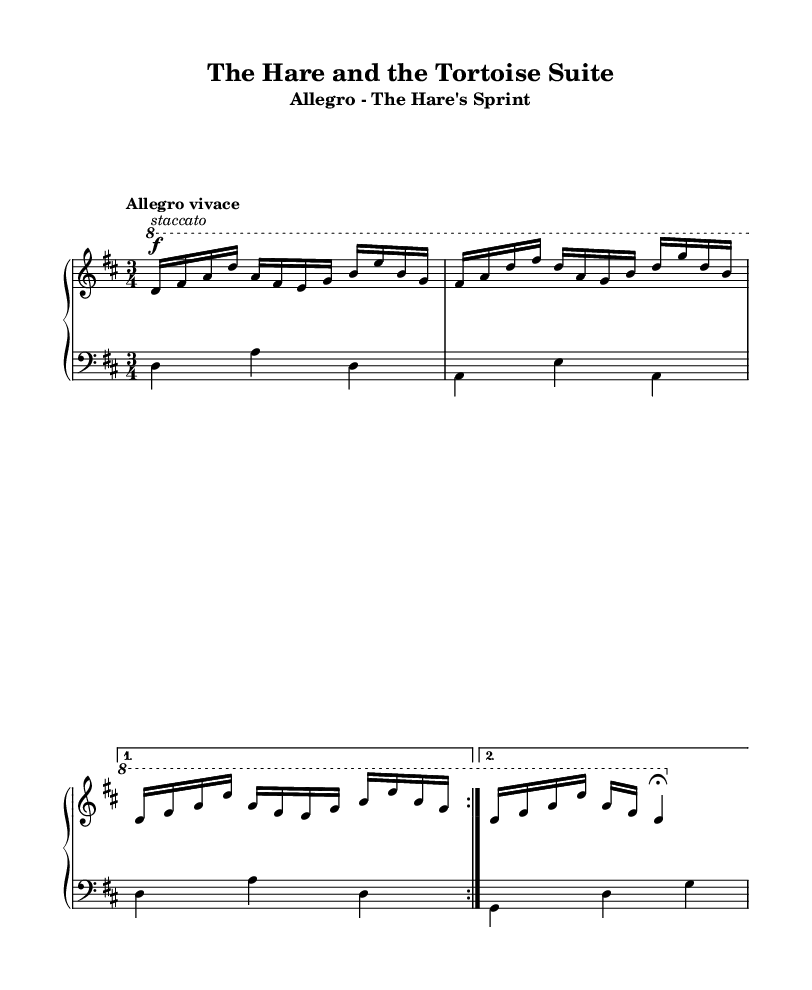What is the key signature of this music? The key signature is D major, which has two sharps (F# and C#). This can be deduced from the initial part of the score beneath the staff, indicating the key signature that governs the piece.
Answer: D major What is the time signature of this music? The time signature shown in the score is 3/4. This indicates that there are three beats in each measure and that a quarter note receives one beat. The time signature is typically found at the beginning of the staff, where it is prominently displayed.
Answer: 3/4 What is the tempo marking for this piece? The tempo marking is "Allegro vivace". This marking signifies a fast and lively tempo, indicating the speed and mood of the piece. Tempo markings are usually presented at the start of the music to guide the performer.
Answer: Allegro vivace How many times does the main motif repeat in the right hand? The main motif in the right hand repeats two times, as indicated by the notation of "volta 2", which shows repeated sections in the music. This repetition is typical in Baroque music, reinforcing the theme.
Answer: 2 What is the dynamic marking for the first section of the right hand? The dynamic marking for the first section of the right hand is "f" for forte. This indicates that the passage should be played loudly. The dynamic markings are typically placed before the notes they influence to instruct the performer how to express the music.
Answer: forte What is the phrase structure of the left hand in the repeated section? The phrase structure of the left hand in the repeated section consists of two measures, repeated two times. Each measure contributes to the harmonic foundation that supports the right-hand melody, common in Baroque suites.
Answer: 2 measures 